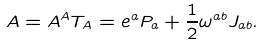Convert formula to latex. <formula><loc_0><loc_0><loc_500><loc_500>A = A ^ { A } T _ { A } = e ^ { a } P _ { a } + \frac { 1 } { 2 } \omega ^ { a b } J _ { a b } .</formula> 